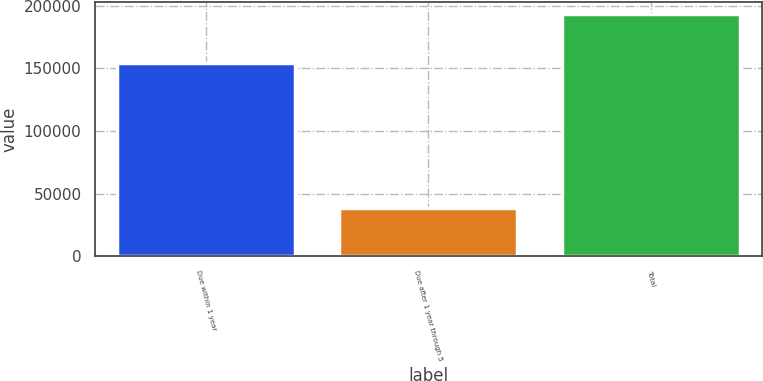Convert chart to OTSL. <chart><loc_0><loc_0><loc_500><loc_500><bar_chart><fcel>Due within 1 year<fcel>Due after 1 year through 5<fcel>Total<nl><fcel>154566<fcel>38797<fcel>193363<nl></chart> 